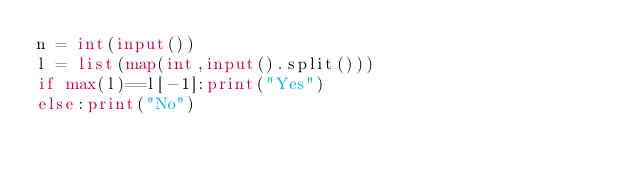Convert code to text. <code><loc_0><loc_0><loc_500><loc_500><_Python_>n = int(input())
l = list(map(int,input().split()))
if max(l)==l[-1]:print("Yes")
else:print("No")</code> 